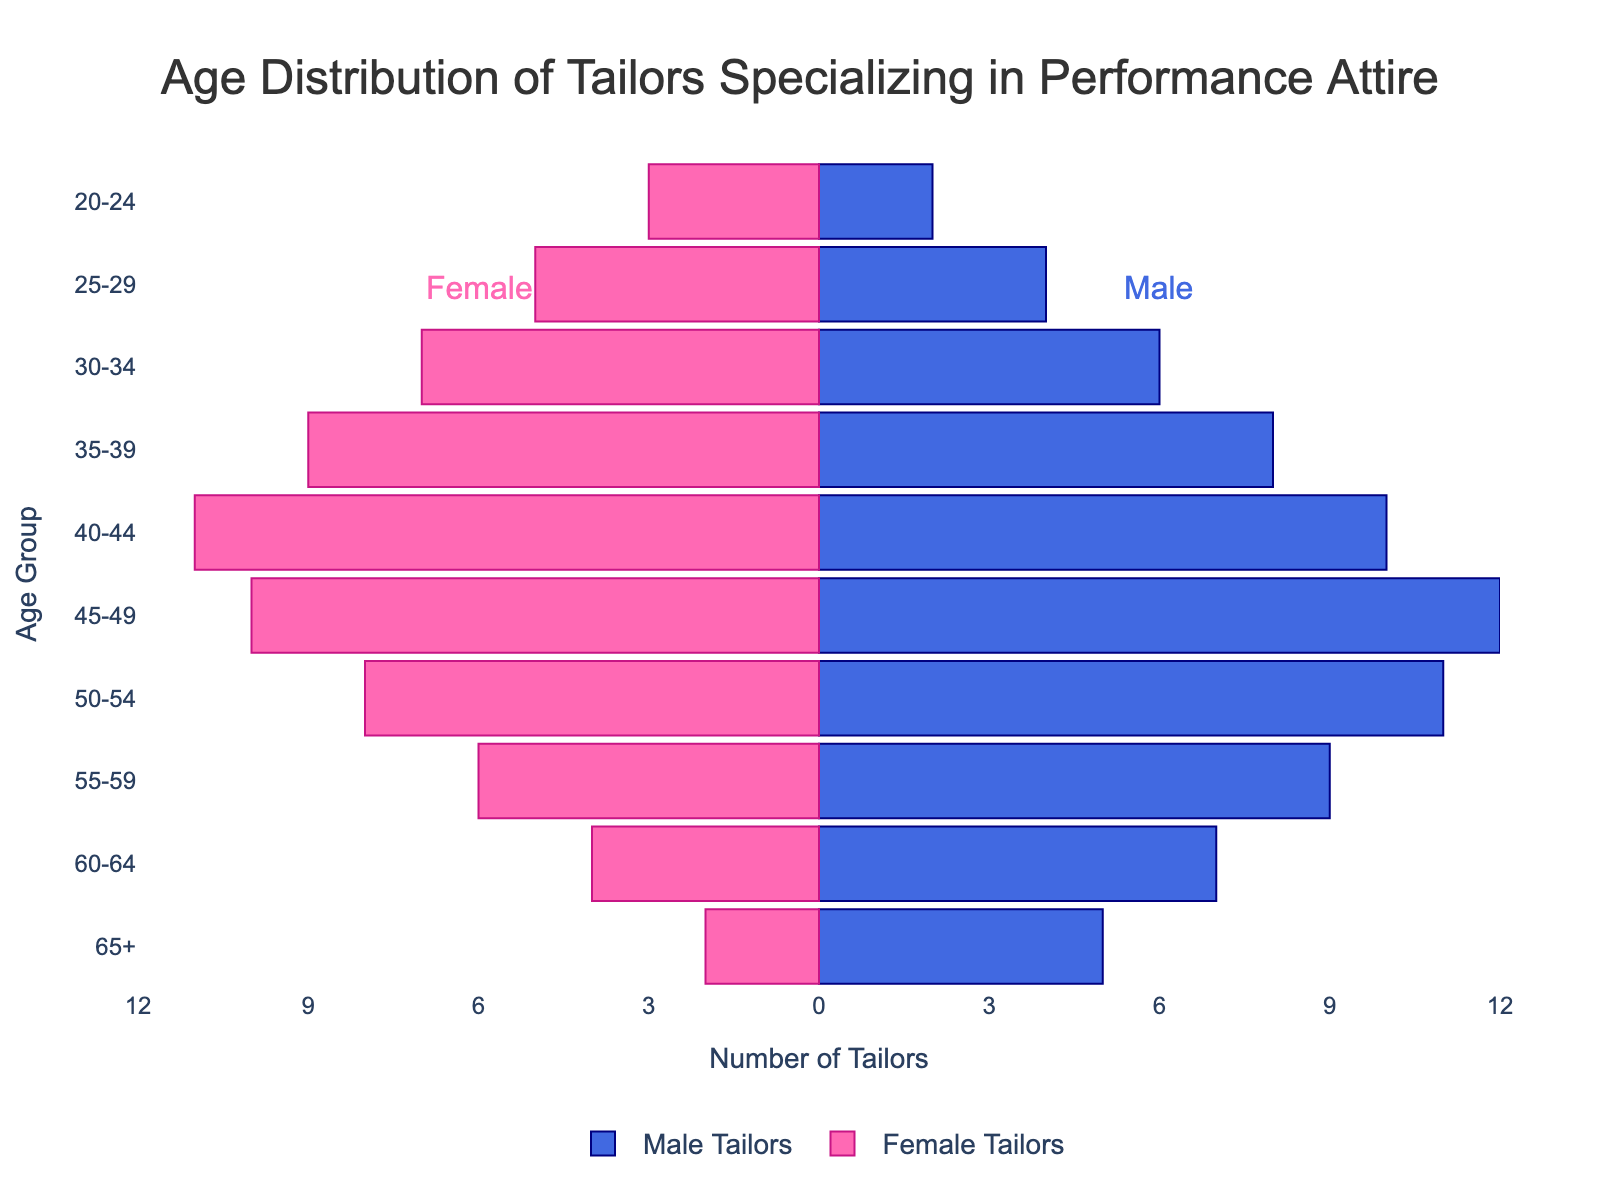What is the title of the figure? The title of the figure is typically found at the top, and it is clearly labeled to indicate what the graph is illustrating. In this case, the title is "Age Distribution of Tailors Specializing in Performance Attire," which summarizes the data being presented.
Answer: Age Distribution of Tailors Specializing in Performance Attire What is the age group with the highest number of male tailors? First, identify the bars representing male tailors, which are on the right side of the population pyramid. Then, find the bar with the longest length. The age group attached to this bar is the one with the highest number of male tailors.
Answer: 45-49 How many female tailors are in the 40-44 age group? Look at the left side of the population pyramid where the female tailors are represented by pink bars. Find the bar corresponding to the 40-44 age group and read the value.
Answer: 11 Which gender has more tailors in the 25-29 age group? Compare the lengths of the male and female bars for the 25-29 age group. Identify which side has the longer bar.
Answer: Female What is the total number of tailors in the 50-54 age group? Add the number of male tailors and female tailors in the 50-54 age group. The male tailors are represented by the blue bar (11), and the female tailors by the negative pink bar (8). 11 + 8 equals 19.
Answer: 19 What is the difference in the number of male and female tailors in the 45-49 age group? Find the numbers for male (12) and female (10) tailors in the 45-49 age group. Subtract the smaller number (female) from the larger number (male). 12 - 10 equals 2.
Answer: 2 How many age groups have more female tailors than male tailors? For each age group, compare the lengths of the male and female bars to determine which one is longer. Count how many times the female bar is longer. By reviewing each bar, it can be found that there are 4 age groups where the number of female tailors exceeds the number of male tailors (20-24, 25-29, 30-34, 35-39).
Answer: 4 Which age group has the most balanced number of male and female tailors? Check the bars to see where the lengths of male and female tailors are closest to each other. This is the age group where the difference between their numbers is the smallest. In this figure, the 45-49 age group is the most balanced, with male tailors at 12 and female tailors at 10, showing the smallest difference of 2.
Answer: 45-49 What is the sum of male tailors in the 55-59 and 65+ age groups? Identify the number of male tailors in each age group. For 55-59, there are 9 male tailors, and for 65+ there are 5 male tailors. Sum these numbers. 9 + 5 = 14.
Answer: 14 